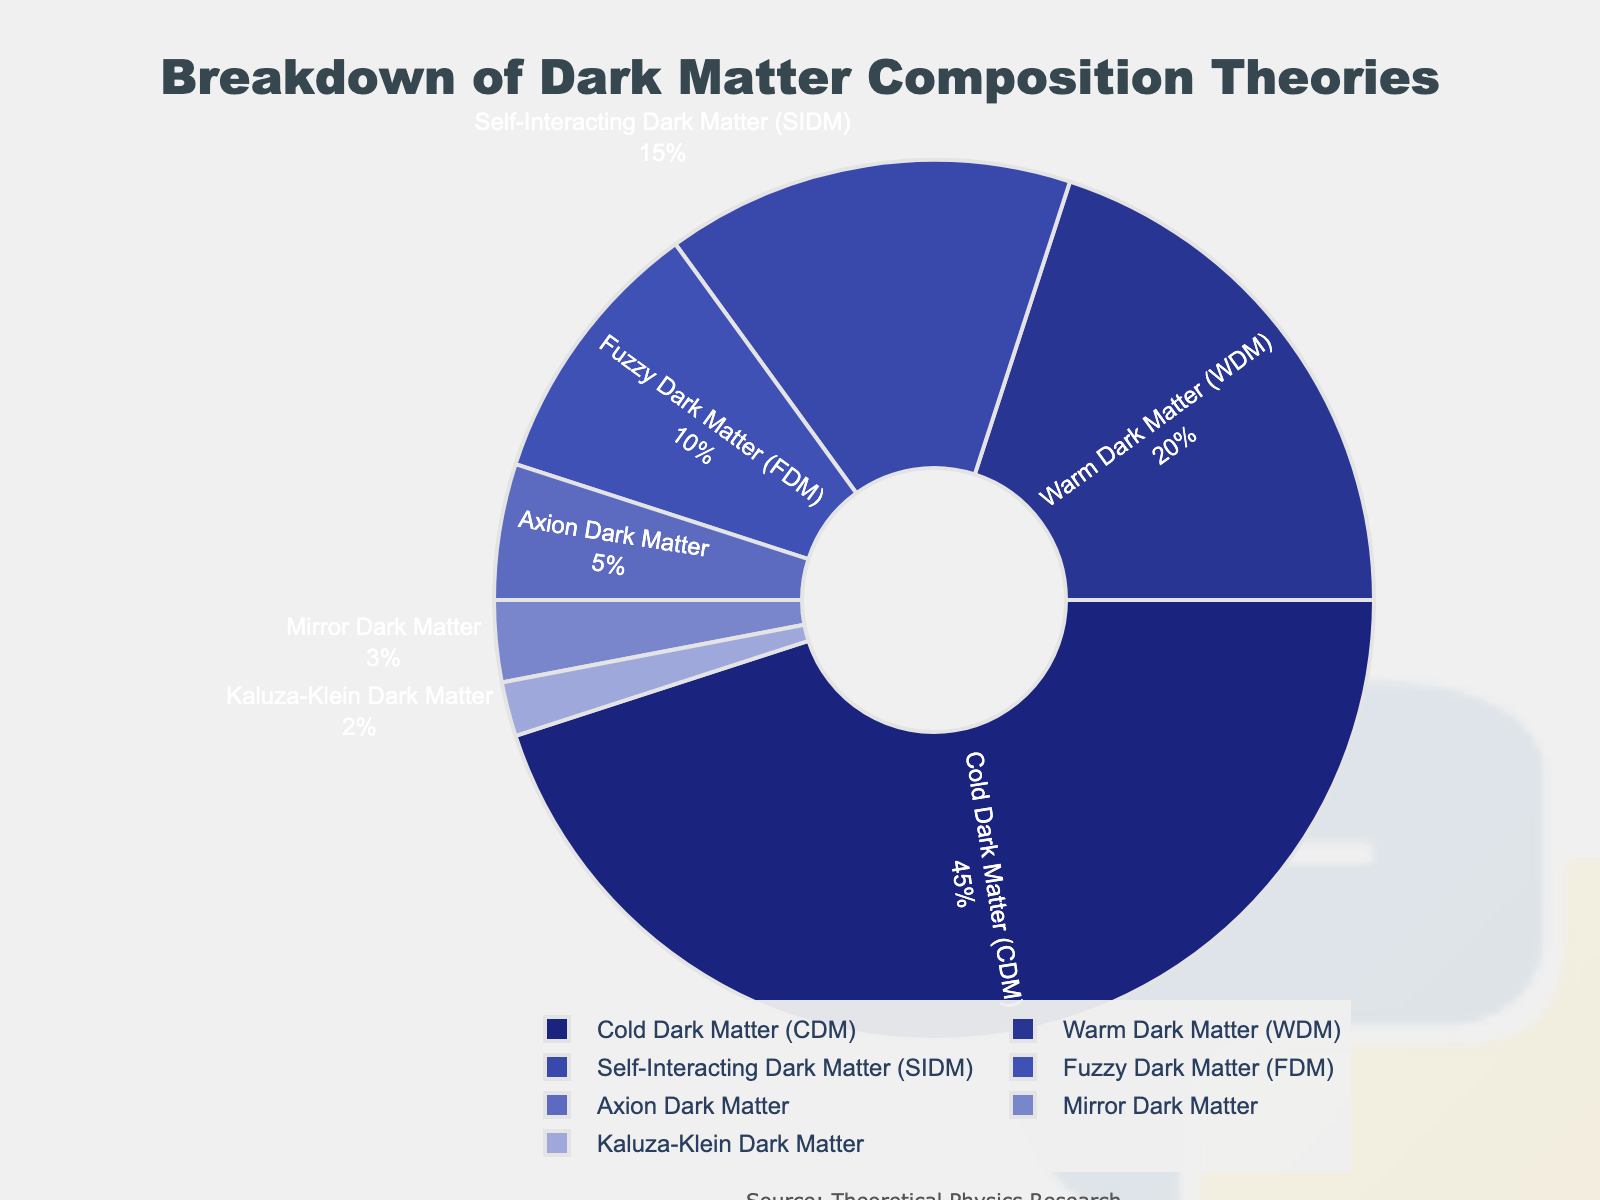Which dark matter theory has the highest composition percentage? The theory with the highest composition percentage is "Cold Dark Matter (CDM)" at 45%, as indicated by the largest segment in the pie chart.
Answer: Cold Dark Matter (CDM) Which two dark matter theories together make up over 60% of the total? "Cold Dark Matter (CDM)" and "Warm Dark Matter (WDM)" together make up 65% of the total (45% + 20%), as shown by summing their respective segments in the pie chart.
Answer: Cold Dark Matter (CDM) and Warm Dark Matter (WDM) What is the difference in composition between Self-Interacting Dark Matter (SIDM) and Axion Dark Matter? Self-Interacting Dark Matter (SIDM) is 15% while Axion Dark Matter is 5%. The difference is calculated as 15% - 5% = 10%.
Answer: 10% How many theories account for less than 10% each? The theories that account for less than 10% each are "Axion Dark Matter" (5%), "Mirror Dark Matter" (3%), and "Kaluza-Klein Dark Matter" (2%). There are three such theories.
Answer: 3 Is the percentage of Fuzzy Dark Matter (FDM) greater than that of Axion Dark Matter and Mirror Dark Matter combined? Fuzzy Dark Matter (FDM) is 10%, while Axion Dark Matter (5%) + Mirror Dark Matter (3%) is 8%. Since 10% > 8%, FDM is greater than the combined percentage of Axion and Mirror Dark Matter.
Answer: Yes What is the weighted average composition percentage of all theories, given their respective percentages? To calculate the weighted average: (45% + 20% + 15% + 10% + 5% + 3% + 2%) / 7 ≈ 14.29%. Add all percentages: 45+20+15+10+5+3+2 = 100, then divide by 7 (the number of theories).
Answer: 14.29% Which segment is the smallest, and what is its percentage? The smallest segment on the pie chart is "Kaluza-Klein Dark Matter," which has a percentage of 2%. It's the smallest visual segment.
Answer: Kaluza-Klein Dark Matter, 2% By how much does the percentage of Warm Dark Matter (WDM) exceed that of Fuzzy Dark Matter (FDM)? Warm Dark Matter (WDM) is 20%, while Fuzzy Dark Matter (FDM) is 10%. The difference is 20% - 10% = 10%.
Answer: 10% 